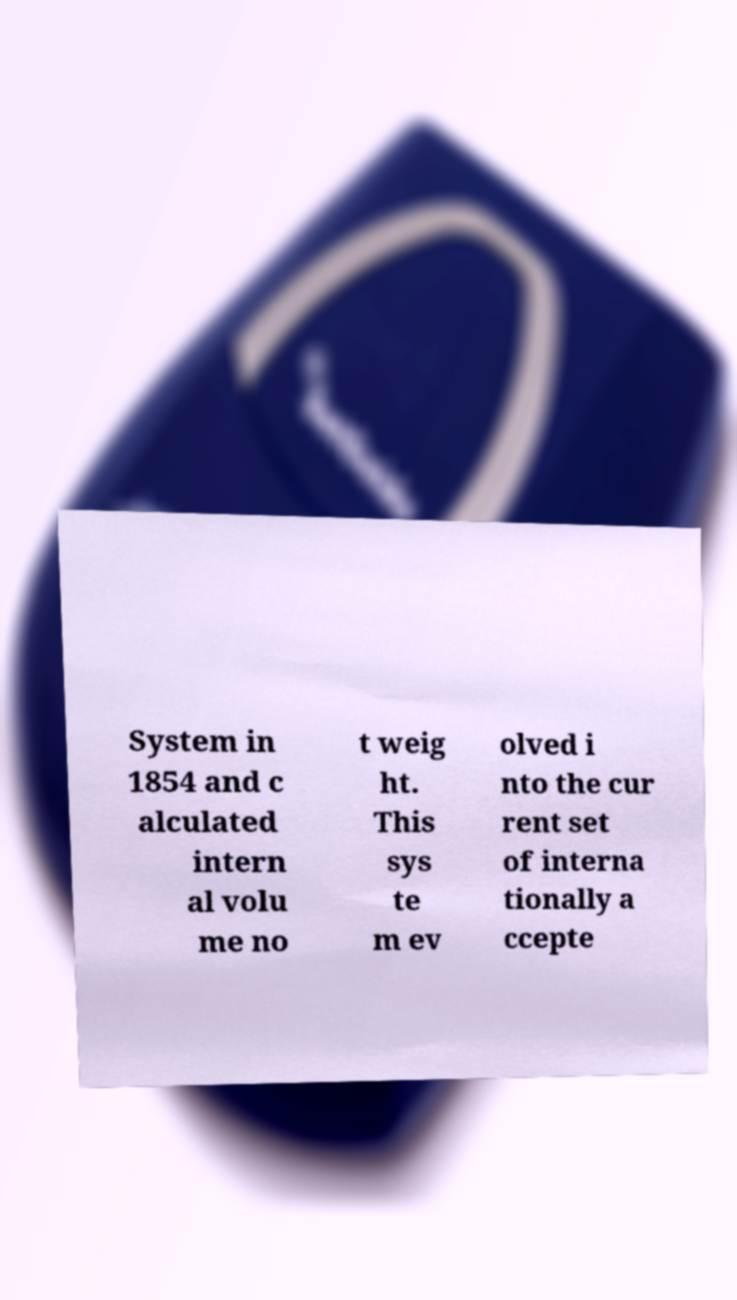I need the written content from this picture converted into text. Can you do that? System in 1854 and c alculated intern al volu me no t weig ht. This sys te m ev olved i nto the cur rent set of interna tionally a ccepte 